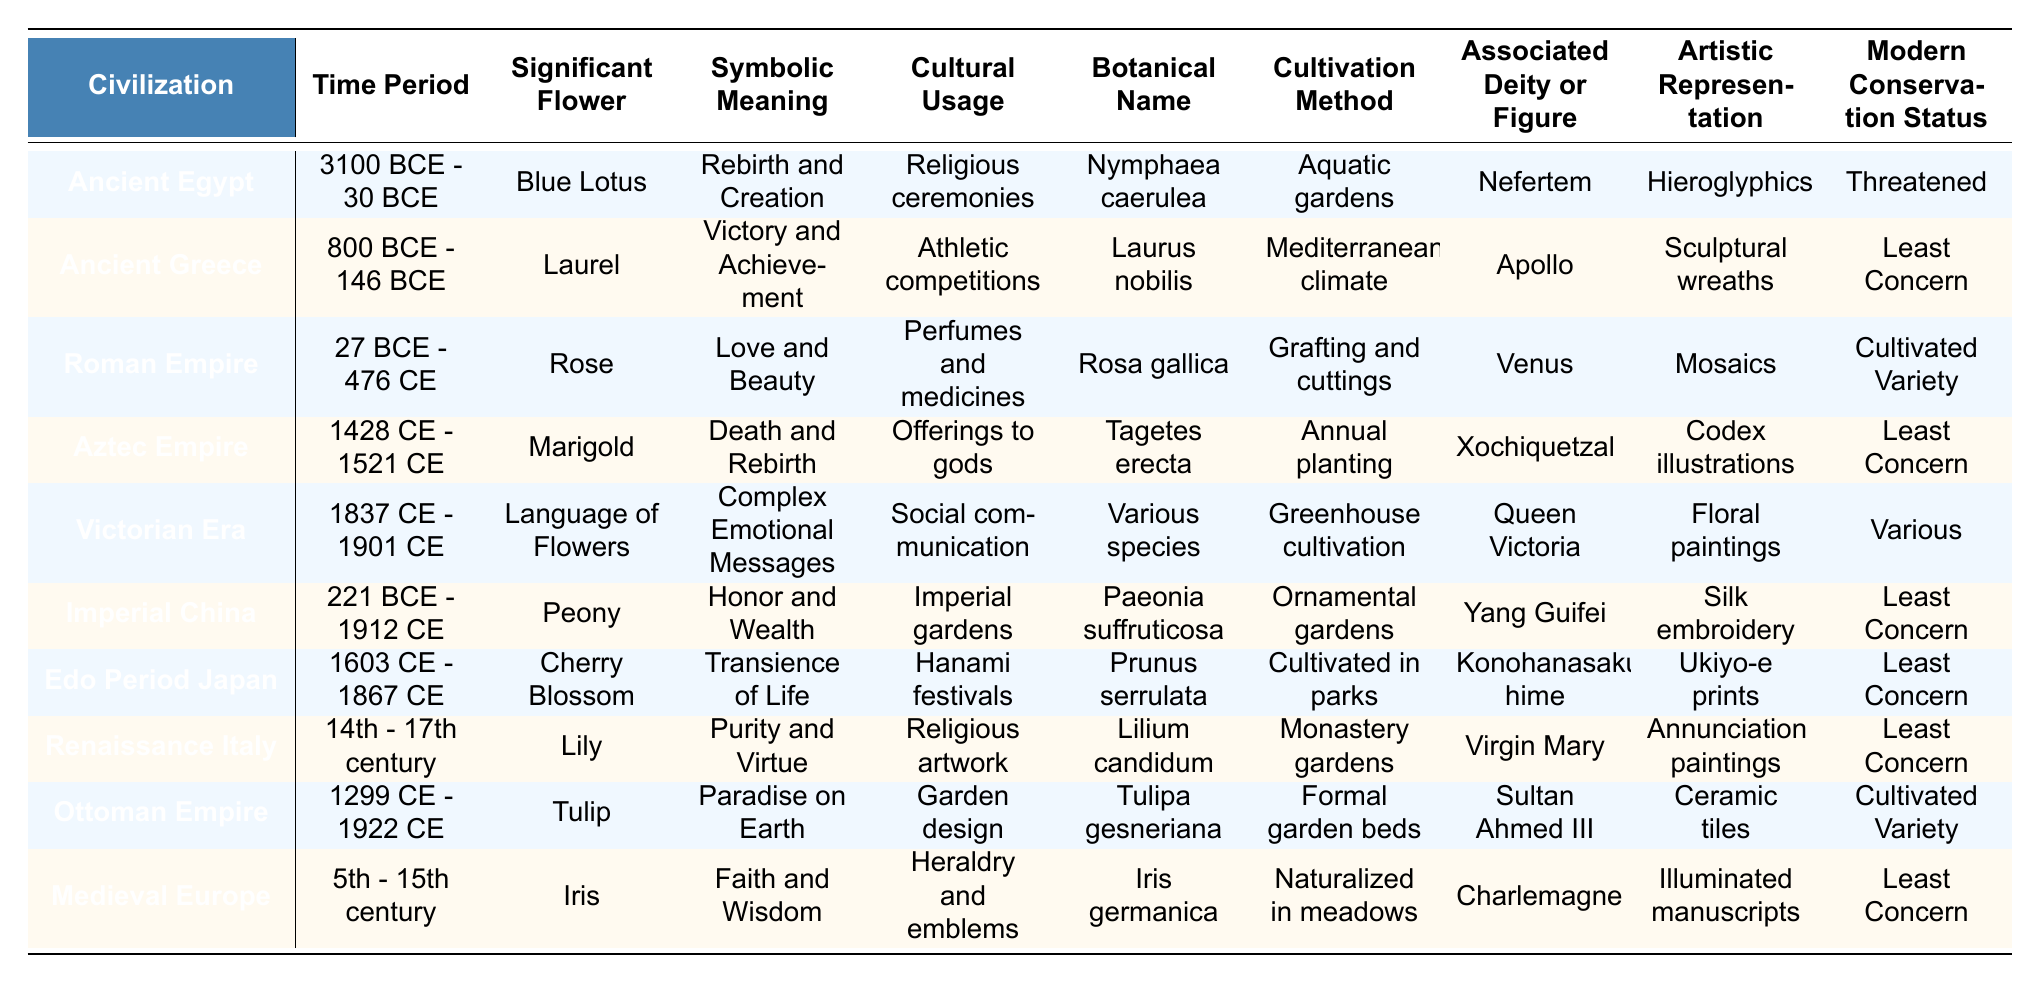What flower is associated with Ancient Greece? The table lists the significant flowers for each civilization, and for Ancient Greece, the flower is Laurel.
Answer: Laurel What is the symbolic meaning of the Tulip in the Ottoman Empire? According to the table, the Tulip symbolizes "Paradise on Earth" in the context of the Ottoman Empire.
Answer: Paradise on Earth Which civilization used the Blue Lotus for religious ceremonies? The table specifies that Ancient Egypt used the Blue Lotus in religious ceremonies.
Answer: Ancient Egypt How many civilizations are associated with flowers symbolizing love or beauty? From the table, both Ancient Greece (Laurel) and the Roman Empire (Rose) symbolize love or beauty, making it two civilizations.
Answer: 2 Does the Peony have a Least Concern status in modern conservation? The table indicates that the modern conservation status of Peony is "Least Concern."
Answer: Yes What are the two significant flowers from the Medieval Europe and the Victorian Era? The table shows that the significant flower for Medieval Europe is Iris, while for the Victorian Era it is Language of Flowers.
Answer: Iris and Language of Flowers Which flower was cultivated in parks during the Edo Period Japan? The table reveals that during the Edo Period Japan, the Cherry Blossom was cultivated in parks.
Answer: Cherry Blossom What is the most common modern conservation status across the civilizations listed? Upon reviewing the table, the majority of civilizations (6 out of 10) have a status of "Least Concern."
Answer: Least Concern What flower is associated with the goddess Xochiquetzal in the Aztec Empire? According to the table, the flower associated with the goddess Xochiquetzal is Marigold.
Answer: Marigold Which civilization’s significant flower involves complex emotional messages? The table points out that the Victorian Era uses the Language of Flowers to convey complex emotional messages.
Answer: Victorian Era In which civilization was the flower associated with victory planted in a Mediterranean climate? The table describes the Laurel flower associated with Ancient Greece, which was planted in a Mediterranean climate.
Answer: Ancient Greece 